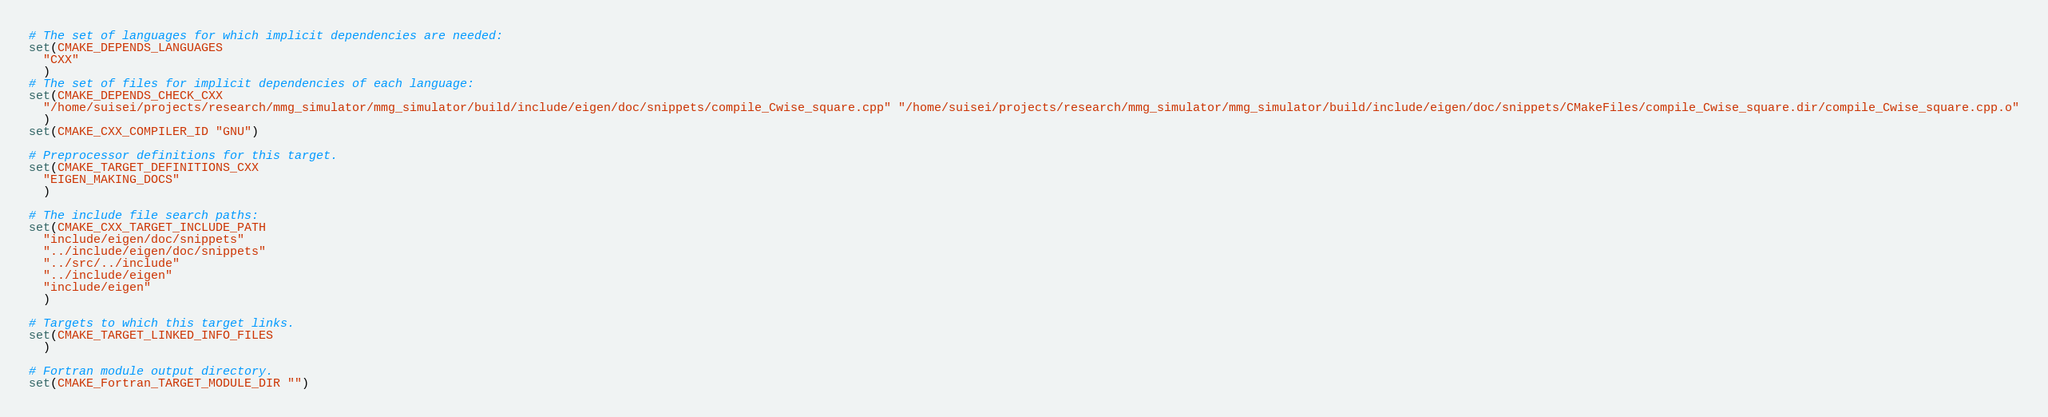Convert code to text. <code><loc_0><loc_0><loc_500><loc_500><_CMake_># The set of languages for which implicit dependencies are needed:
set(CMAKE_DEPENDS_LANGUAGES
  "CXX"
  )
# The set of files for implicit dependencies of each language:
set(CMAKE_DEPENDS_CHECK_CXX
  "/home/suisei/projects/research/mmg_simulator/mmg_simulator/build/include/eigen/doc/snippets/compile_Cwise_square.cpp" "/home/suisei/projects/research/mmg_simulator/mmg_simulator/build/include/eigen/doc/snippets/CMakeFiles/compile_Cwise_square.dir/compile_Cwise_square.cpp.o"
  )
set(CMAKE_CXX_COMPILER_ID "GNU")

# Preprocessor definitions for this target.
set(CMAKE_TARGET_DEFINITIONS_CXX
  "EIGEN_MAKING_DOCS"
  )

# The include file search paths:
set(CMAKE_CXX_TARGET_INCLUDE_PATH
  "include/eigen/doc/snippets"
  "../include/eigen/doc/snippets"
  "../src/../include"
  "../include/eigen"
  "include/eigen"
  )

# Targets to which this target links.
set(CMAKE_TARGET_LINKED_INFO_FILES
  )

# Fortran module output directory.
set(CMAKE_Fortran_TARGET_MODULE_DIR "")
</code> 